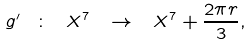Convert formula to latex. <formula><loc_0><loc_0><loc_500><loc_500>g ^ { \prime } \ \colon \ X ^ { 7 } \ \to \ X ^ { 7 } + \frac { 2 \pi r } 3 ,</formula> 